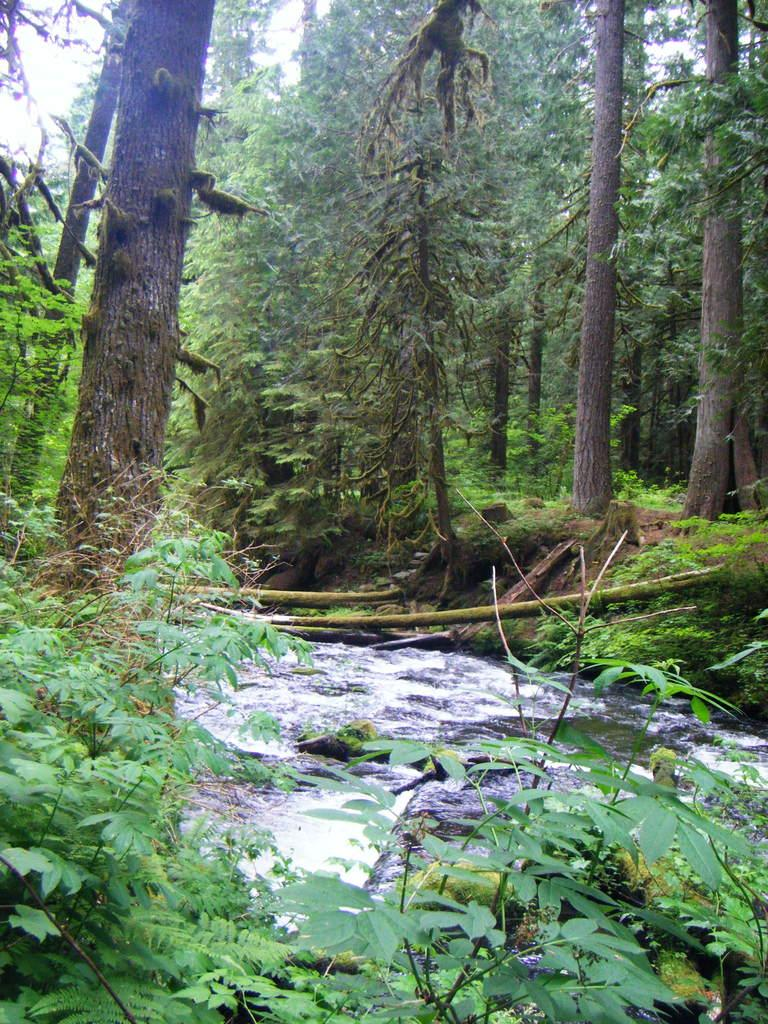What type of vegetation can be seen in the image? There are trees in the image. What natural feature is present among the trees? There is a water flow in the image. Where is the water flow located in relation to the trees? The water flow is located in the middle of the trees. What can be seen in the background of the image? The sky is visible in the background of the image. How many snails can be seen crawling on the maid in the image? There are no snails or maids present in the image. What is the taste of the water flow in the image? The taste of the water flow cannot be determined from the image, as taste is not a visual characteristic. 